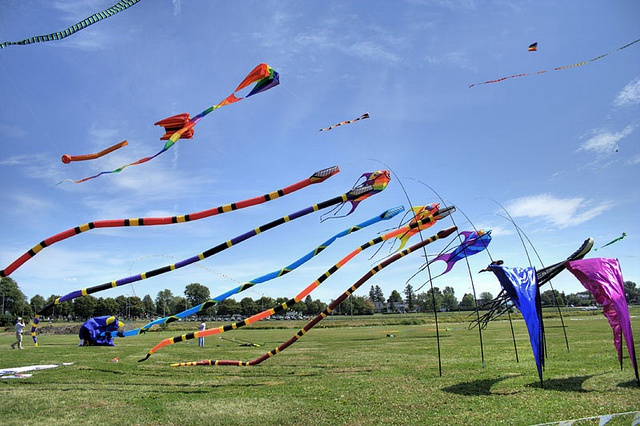Describe the objects in this image and their specific colors. I can see kite in gray, black, lightblue, red, and olive tones, kite in gray, black, navy, darkgray, and lightblue tones, kite in gray, purple, and black tones, kite in gray, brown, maroon, darkgray, and black tones, and kite in gray, brown, maroon, black, and olive tones in this image. 